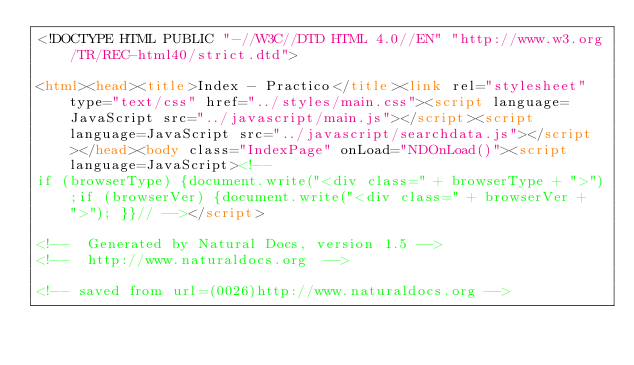<code> <loc_0><loc_0><loc_500><loc_500><_HTML_><!DOCTYPE HTML PUBLIC "-//W3C//DTD HTML 4.0//EN" "http://www.w3.org/TR/REC-html40/strict.dtd">

<html><head><title>Index - Practico</title><link rel="stylesheet" type="text/css" href="../styles/main.css"><script language=JavaScript src="../javascript/main.js"></script><script language=JavaScript src="../javascript/searchdata.js"></script></head><body class="IndexPage" onLoad="NDOnLoad()"><script language=JavaScript><!--
if (browserType) {document.write("<div class=" + browserType + ">");if (browserVer) {document.write("<div class=" + browserVer + ">"); }}// --></script>

<!--  Generated by Natural Docs, version 1.5 -->
<!--  http://www.naturaldocs.org  -->

<!-- saved from url=(0026)http://www.naturaldocs.org -->



</code> 